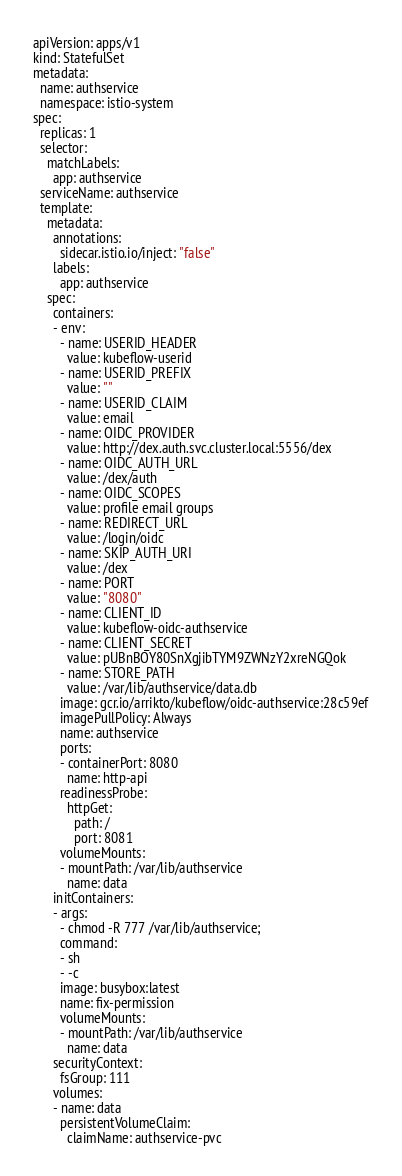<code> <loc_0><loc_0><loc_500><loc_500><_YAML_>apiVersion: apps/v1
kind: StatefulSet
metadata:
  name: authservice
  namespace: istio-system
spec:
  replicas: 1
  selector:
    matchLabels:
      app: authservice
  serviceName: authservice
  template:
    metadata:
      annotations:
        sidecar.istio.io/inject: "false"
      labels:
        app: authservice
    spec:
      containers:
      - env:
        - name: USERID_HEADER
          value: kubeflow-userid
        - name: USERID_PREFIX
          value: ""
        - name: USERID_CLAIM
          value: email
        - name: OIDC_PROVIDER
          value: http://dex.auth.svc.cluster.local:5556/dex
        - name: OIDC_AUTH_URL
          value: /dex/auth
        - name: OIDC_SCOPES
          value: profile email groups
        - name: REDIRECT_URL
          value: /login/oidc
        - name: SKIP_AUTH_URI
          value: /dex
        - name: PORT
          value: "8080"
        - name: CLIENT_ID
          value: kubeflow-oidc-authservice
        - name: CLIENT_SECRET
          value: pUBnBOY80SnXgjibTYM9ZWNzY2xreNGQok
        - name: STORE_PATH
          value: /var/lib/authservice/data.db
        image: gcr.io/arrikto/kubeflow/oidc-authservice:28c59ef
        imagePullPolicy: Always
        name: authservice
        ports:
        - containerPort: 8080
          name: http-api
        readinessProbe:
          httpGet:
            path: /
            port: 8081
        volumeMounts:
        - mountPath: /var/lib/authservice
          name: data
      initContainers:
      - args:
        - chmod -R 777 /var/lib/authservice;
        command:
        - sh
        - -c
        image: busybox:latest
        name: fix-permission
        volumeMounts:
        - mountPath: /var/lib/authservice
          name: data
      securityContext:
        fsGroup: 111
      volumes:
      - name: data
        persistentVolumeClaim:
          claimName: authservice-pvc
</code> 